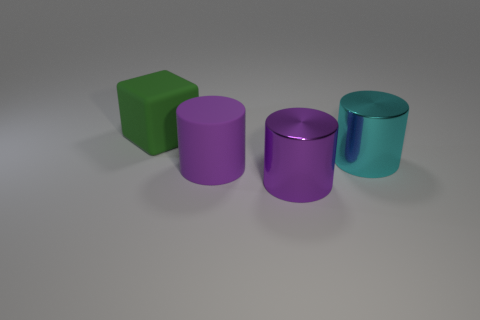There is a cyan object; is it the same shape as the big rubber thing in front of the block?
Your answer should be compact. Yes. There is a object that is made of the same material as the cube; what is its color?
Give a very brief answer. Purple. The rubber block is what color?
Offer a terse response. Green. Is the material of the large green object the same as the object on the right side of the big purple metallic cylinder?
Keep it short and to the point. No. What number of large cylinders are right of the purple matte object and on the left side of the big cyan thing?
Your answer should be very brief. 1. There is a purple rubber thing that is the same size as the green matte block; what shape is it?
Keep it short and to the point. Cylinder. Is there a matte thing in front of the purple thing that is in front of the matte thing that is in front of the big rubber block?
Provide a short and direct response. No. There is a block; is it the same color as the large object that is in front of the rubber cylinder?
Your answer should be very brief. No. What number of rubber things have the same color as the cube?
Make the answer very short. 0. There is a matte thing that is behind the cylinder that is behind the purple rubber thing; how big is it?
Offer a very short reply. Large. 